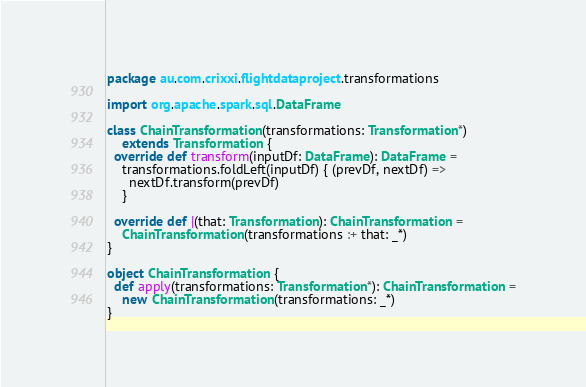Convert code to text. <code><loc_0><loc_0><loc_500><loc_500><_Scala_>package au.com.crixxi.flightdataproject.transformations

import org.apache.spark.sql.DataFrame

class ChainTransformation(transformations: Transformation*)
    extends Transformation {
  override def transform(inputDf: DataFrame): DataFrame =
    transformations.foldLeft(inputDf) { (prevDf, nextDf) =>
      nextDf.transform(prevDf)
    }

  override def |(that: Transformation): ChainTransformation =
    ChainTransformation(transformations :+ that: _*)
}

object ChainTransformation {
  def apply(transformations: Transformation*): ChainTransformation =
    new ChainTransformation(transformations: _*)
}
</code> 